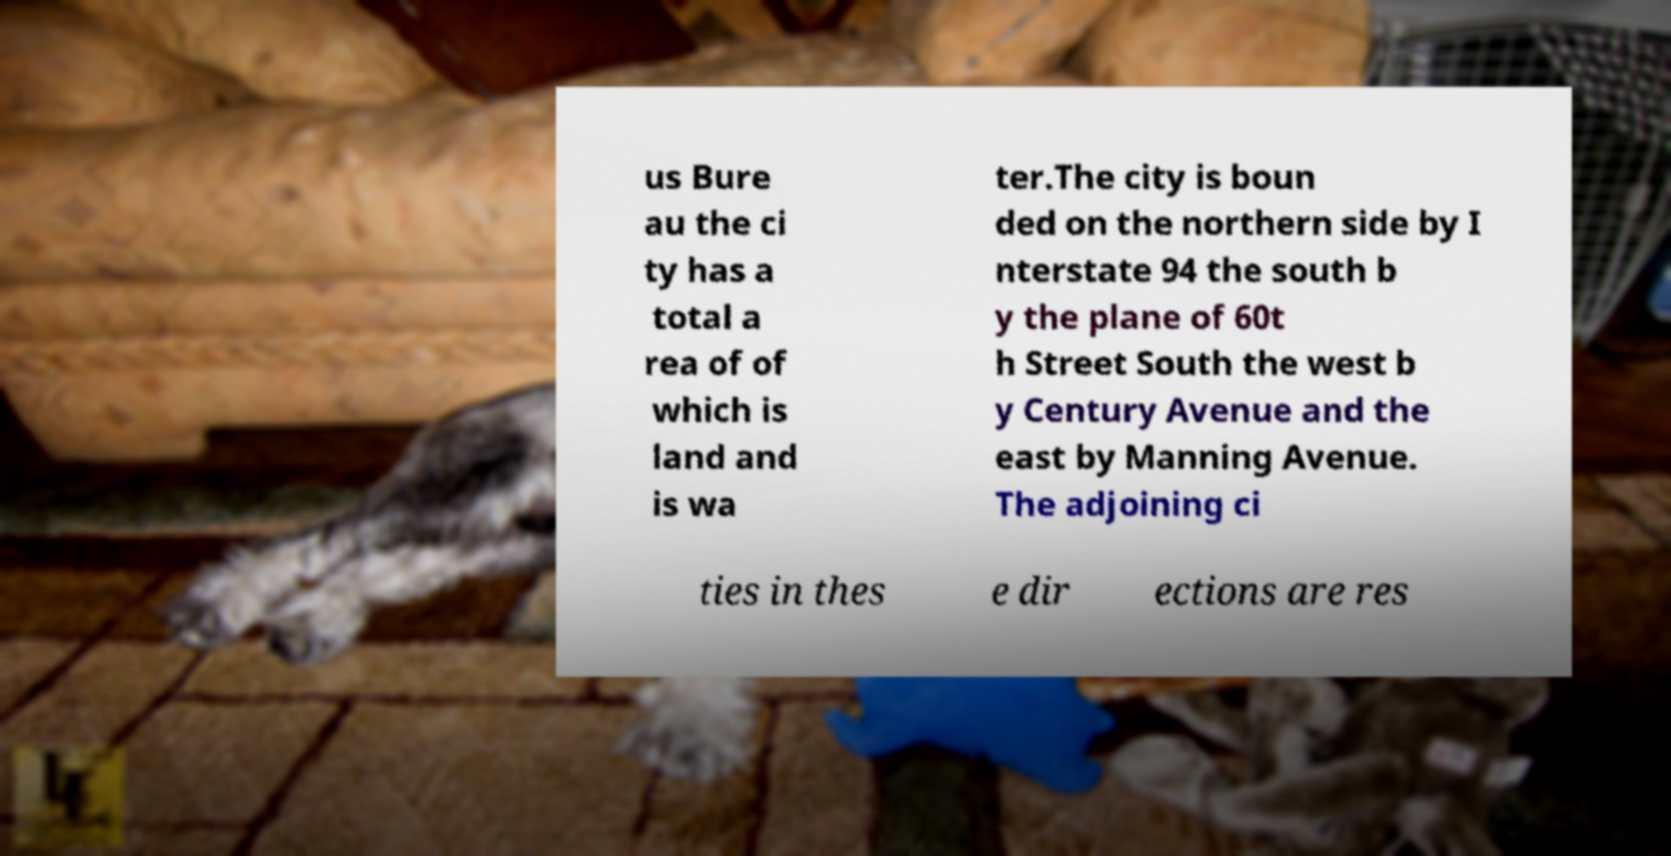Please read and relay the text visible in this image. What does it say? us Bure au the ci ty has a total a rea of of which is land and is wa ter.The city is boun ded on the northern side by I nterstate 94 the south b y the plane of 60t h Street South the west b y Century Avenue and the east by Manning Avenue. The adjoining ci ties in thes e dir ections are res 